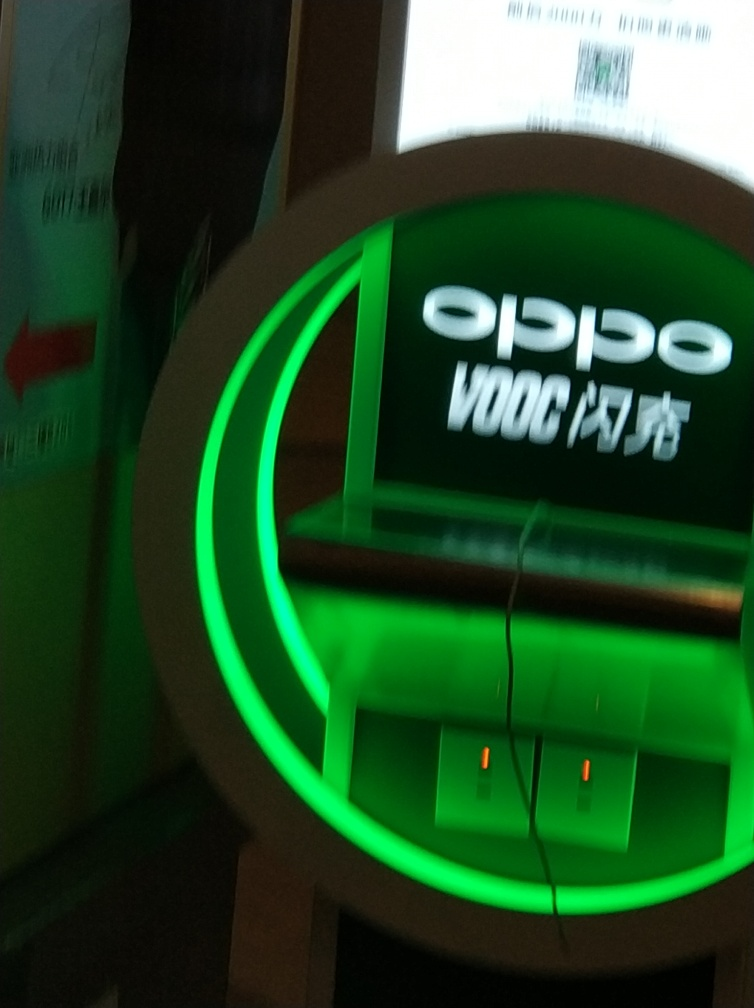What might cause the blurriness in this image? The blurriness in the image is likely due to a combination of motion blur, as the subject or the camera may have moved during the exposure, and possibly a low shutter speed, which is not fast enough to freeze the motion, resulting in a lack of sharpness. 